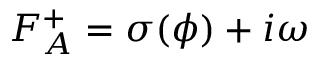Convert formula to latex. <formula><loc_0><loc_0><loc_500><loc_500>F _ { A } ^ { + } = \sigma ( \phi ) + i \omega</formula> 